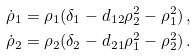Convert formula to latex. <formula><loc_0><loc_0><loc_500><loc_500>\dot { \rho } _ { 1 } & = \rho _ { 1 } ( \delta _ { 1 } - d _ { 1 2 } \rho _ { 2 } ^ { 2 } - \rho _ { 1 } ^ { 2 } ) \, , \\ \dot { \rho } _ { 2 } & = \rho _ { 2 } ( \delta _ { 2 } - d _ { 2 1 } \rho _ { 1 } ^ { 2 } - \rho _ { 2 } ^ { 2 } ) \, .</formula> 